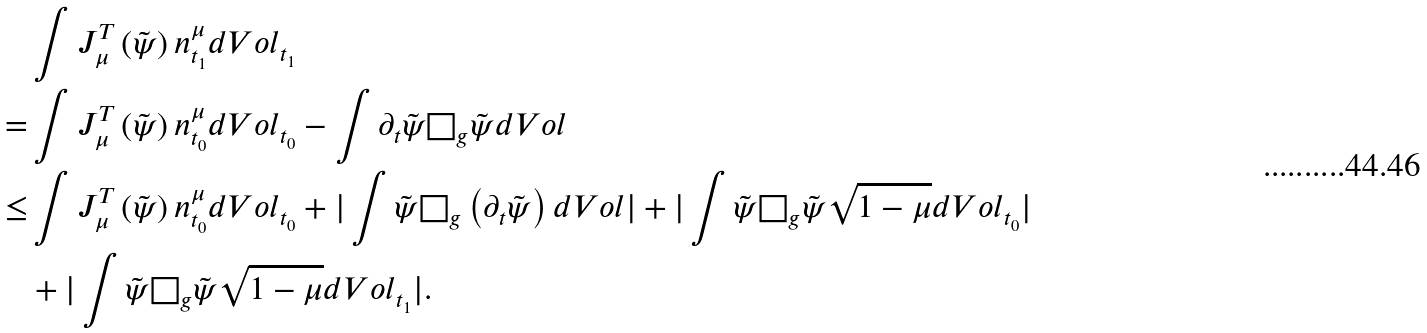Convert formula to latex. <formula><loc_0><loc_0><loc_500><loc_500>& \int J ^ { T } _ { \mu } \left ( \tilde { \psi } \right ) n _ { t _ { 1 } } ^ { \mu } d V o l _ { t _ { 1 } } \\ = & \int J ^ { T } _ { \mu } \left ( \tilde { \psi } \right ) n _ { t _ { 0 } } ^ { \mu } d V o l _ { t _ { 0 } } - \int \partial _ { t } \tilde { \psi } \Box _ { g } \tilde { \psi } d V o l \\ \leq & \int J ^ { T } _ { \mu } \left ( \tilde { \psi } \right ) n _ { t _ { 0 } } ^ { \mu } d V o l _ { t _ { 0 } } + | \int \tilde { \psi } \Box _ { g } \left ( \partial _ { t } \tilde { \psi } \right ) d V o l | + | \int \tilde { \psi } \Box _ { g } \tilde { \psi } \sqrt { 1 - \mu } d V o l _ { t _ { 0 } } | \\ & + | \int \tilde { \psi } \Box _ { g } \tilde { \psi } \sqrt { 1 - \mu } d V o l _ { t _ { 1 } } | .</formula> 